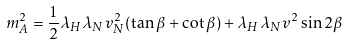<formula> <loc_0><loc_0><loc_500><loc_500>m ^ { 2 } _ { A } = \frac { 1 } { 2 } \lambda _ { H } \lambda _ { N } v ^ { 2 } _ { N } ( \tan \beta + \cot \beta ) + \lambda _ { H } \lambda _ { N } v ^ { 2 } \sin 2 \beta</formula> 